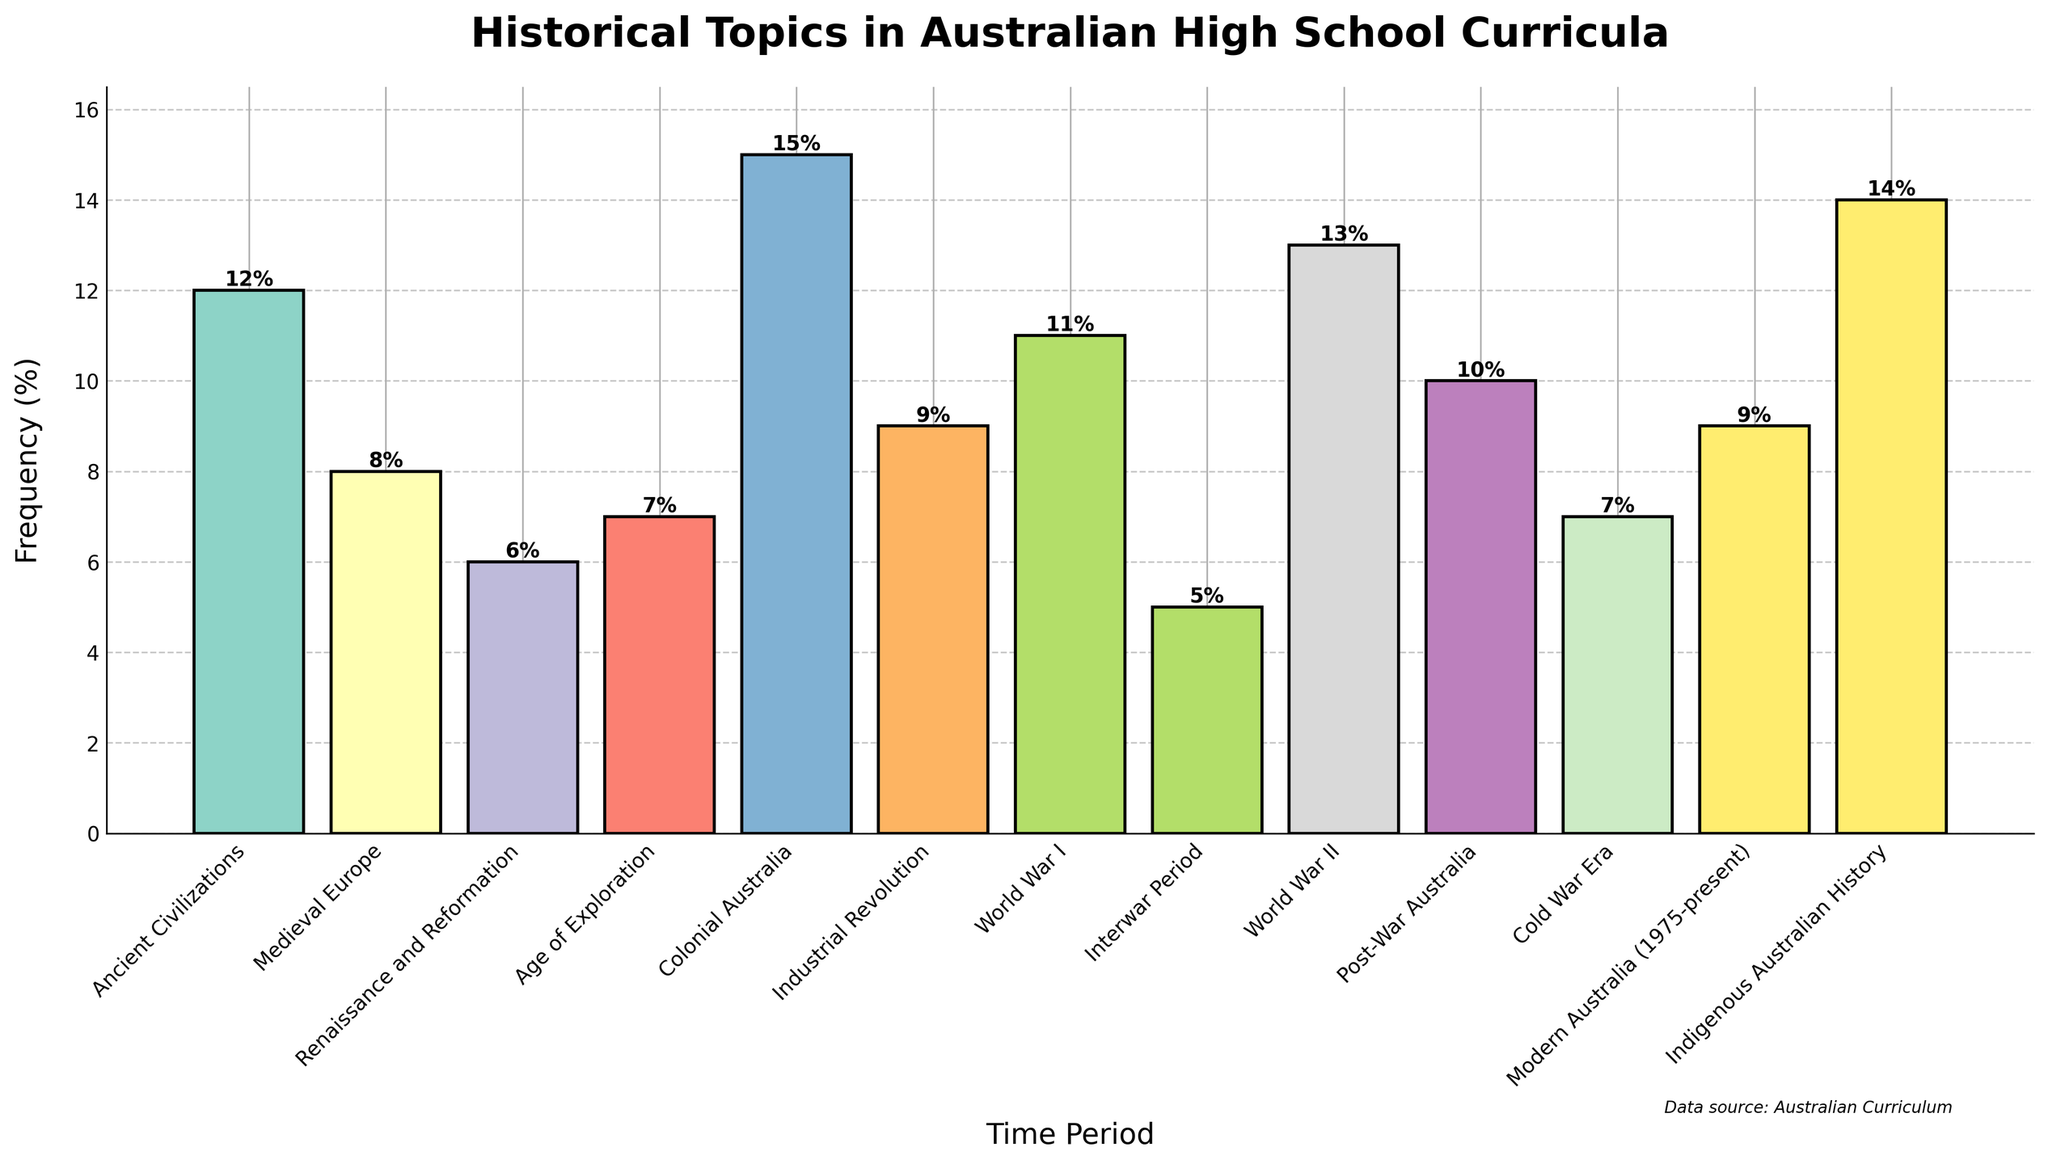Which time period has the highest frequency of coverage in the curricula? Looking at the bar chart, the tallest bar represents Colonial Australia, which indicates it has the highest frequency.
Answer: Colonial Australia Which two time periods have the lowest frequency of coverage, and what are those frequencies? By comparing the heights of the bars, the two shortest bars represent the Interwar Period and Renaissance and Reformation, both with relatively low frequencies.
Answer: Interwar Period (5%), Renaissance and Reformation (6%) What is the total percentage coverage of World War I and World War II combined? Adding the frequencies for World War I (11%) and World War II (13%) gives the total percentage. 11% + 13% = 24%
Answer: 24% How does the frequency of Indigenous Australian History compare to that of Modern Australia (1975-present)? Comparing the heights of the bars, Indigenous Australian History (14%) has a higher frequency than Modern Australia (9%).
Answer: Indigenous Australian History is higher What is the average frequency of coverage across all time periods? To find the average, add all the frequencies and divide by the number of time periods. The total of all frequencies is 12 + 8 + 6 + 7 + 15 + 9 + 11 + 5 + 13 + 10 + 7 + 9 + 14 = 126. There are 13 time periods. 126 / 13 ≈ 9.69
Answer: 9.69% Which time periods have a frequency above 10%? Looking at the bars, the time periods with frequencies above 10% are Colonial Australia (15%), World War II (13%), Indigenous Australian History (14%), and World War I (11%).
Answer: Colonial Australia, World War II, Indigenous Australian History, World War I How much more frequently is Colonial Australia covered compared to the Industrial Revolution? Subtract the frequency of the Industrial Revolution (9%) from that of Colonial Australia (15%). 15% - 9% = 6%
Answer: 6% What is the difference in frequency between Ancient Civilizations and Post-War Australia? Subtract the frequency for Post-War Australia (10%) from that for Ancient Civilizations (12%). 12% - 10% = 2%
Answer: 2% Which time period is represented by the bar colored green? Identifying the color green among the bars, which corresponds to Industrial Revolution.
Answer: Industrial Revolution 